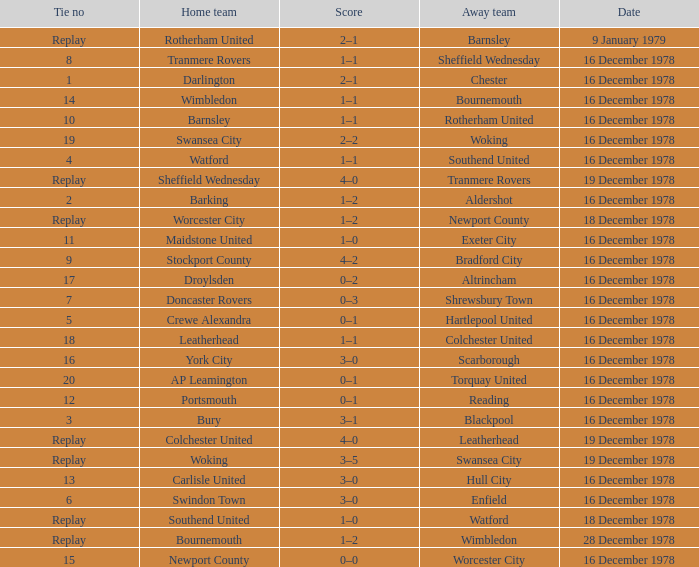What date had a tie no of replay, and an away team of watford? 18 December 1978. 